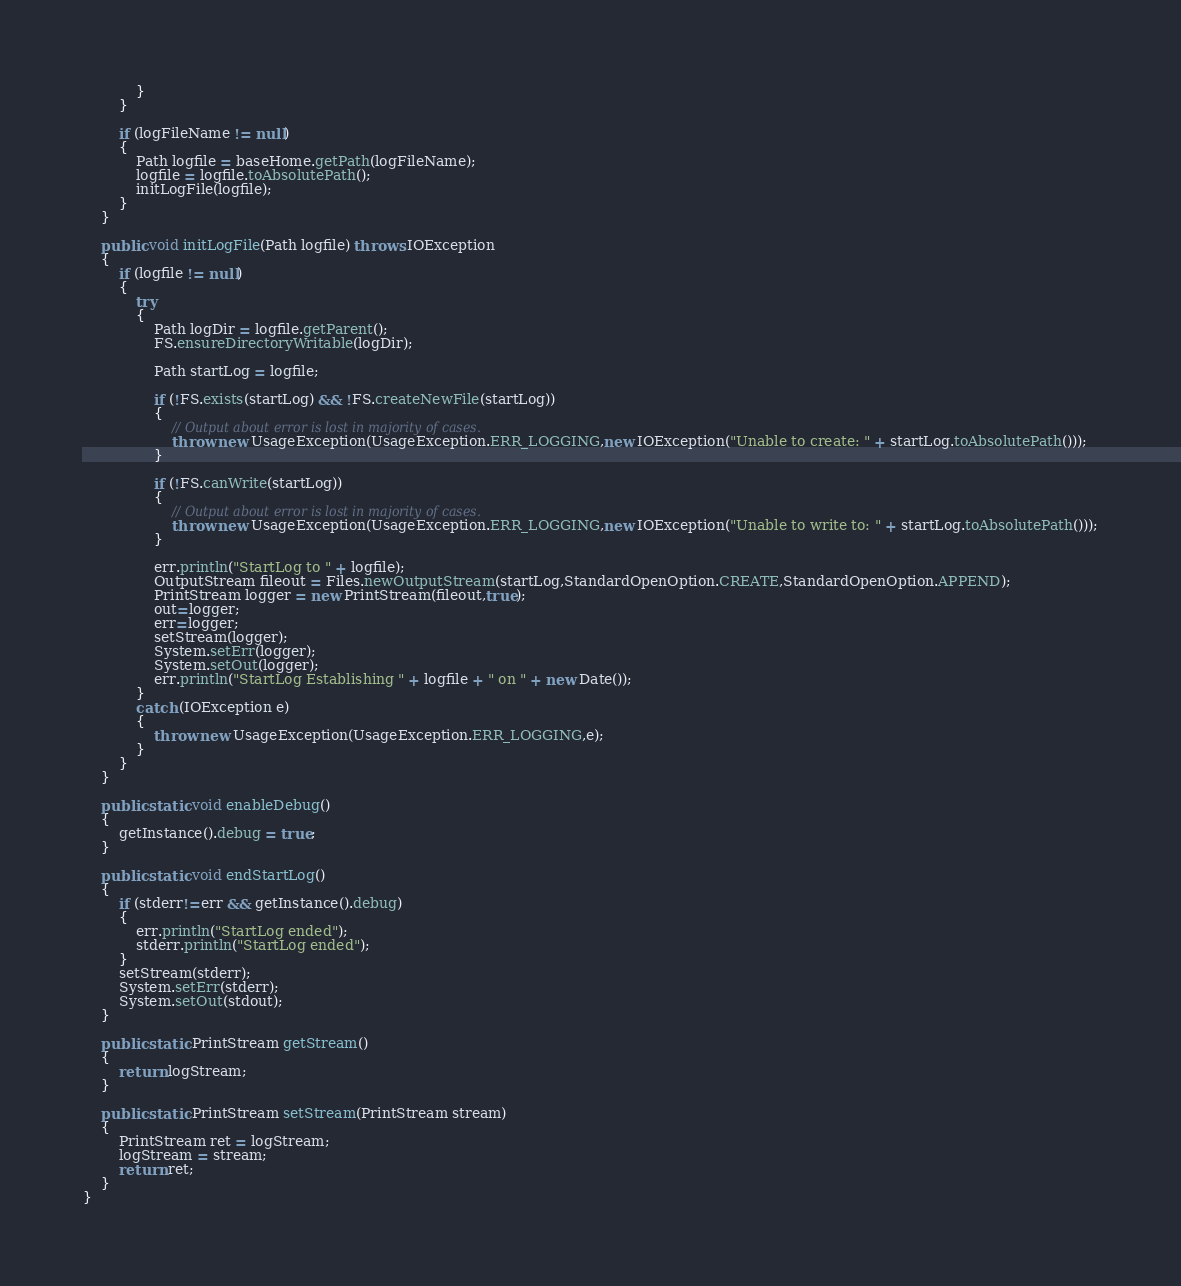Convert code to text. <code><loc_0><loc_0><loc_500><loc_500><_Java_>            }
        }

        if (logFileName != null)
        {
            Path logfile = baseHome.getPath(logFileName);
            logfile = logfile.toAbsolutePath();
            initLogFile(logfile);
        }
    }

    public void initLogFile(Path logfile) throws IOException
    {
        if (logfile != null)
        {
            try
            {
                Path logDir = logfile.getParent();
                FS.ensureDirectoryWritable(logDir);

                Path startLog = logfile;

                if (!FS.exists(startLog) && !FS.createNewFile(startLog))
                {
                    // Output about error is lost in majority of cases.
                    throw new UsageException(UsageException.ERR_LOGGING,new IOException("Unable to create: " + startLog.toAbsolutePath()));
                }

                if (!FS.canWrite(startLog))
                {
                    // Output about error is lost in majority of cases.
                    throw new UsageException(UsageException.ERR_LOGGING,new IOException("Unable to write to: " + startLog.toAbsolutePath()));
                }

                err.println("StartLog to " + logfile);
                OutputStream fileout = Files.newOutputStream(startLog,StandardOpenOption.CREATE,StandardOpenOption.APPEND);
                PrintStream logger = new PrintStream(fileout,true);
                out=logger;
                err=logger;
                setStream(logger);
                System.setErr(logger);
                System.setOut(logger);
                err.println("StartLog Establishing " + logfile + " on " + new Date());
            }
            catch (IOException e)
            {
                throw new UsageException(UsageException.ERR_LOGGING,e);
            }
        }
    }

    public static void enableDebug()
    {
        getInstance().debug = true;
    }
    
    public static void endStartLog()
    {
        if (stderr!=err && getInstance().debug)
        {
            err.println("StartLog ended");
            stderr.println("StartLog ended");
        }
        setStream(stderr);
        System.setErr(stderr);
        System.setOut(stdout);
    }
    
    public static PrintStream getStream()
    {
        return logStream;
    }
    
    public static PrintStream setStream(PrintStream stream)
    {
        PrintStream ret = logStream;
        logStream = stream;
        return ret;
    }
}
</code> 